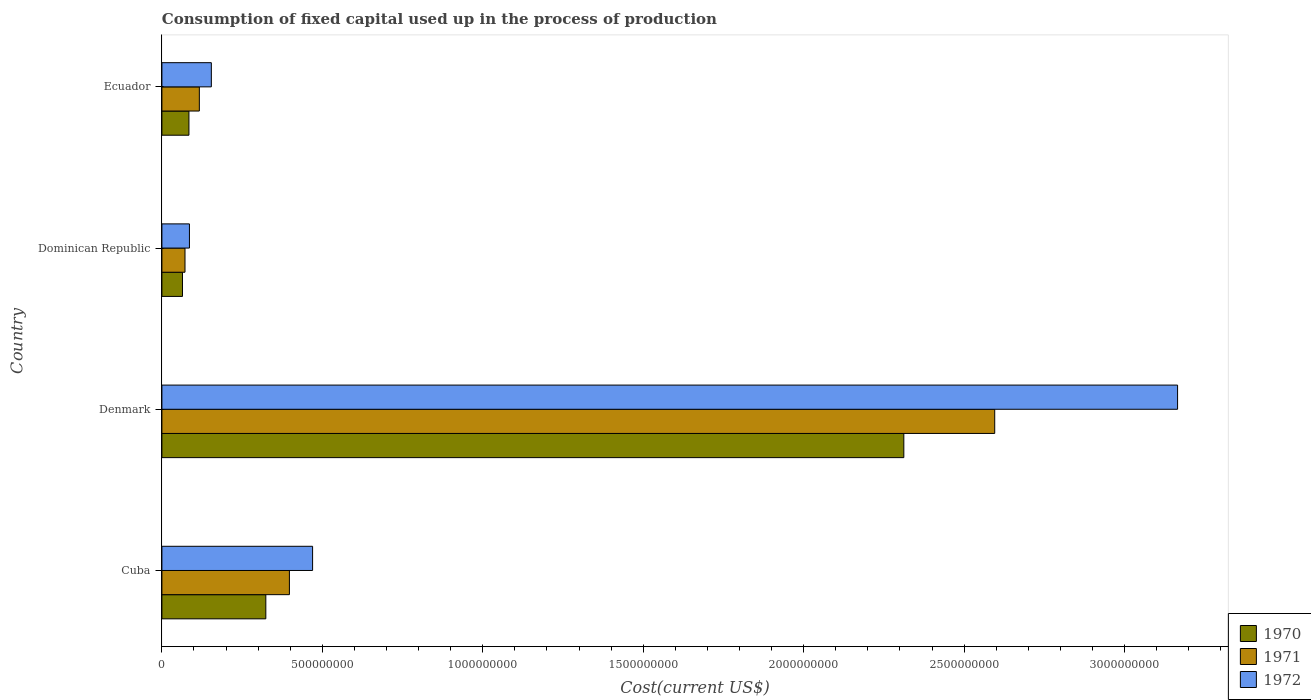How many groups of bars are there?
Your answer should be compact. 4. Are the number of bars per tick equal to the number of legend labels?
Offer a terse response. Yes. Are the number of bars on each tick of the Y-axis equal?
Provide a succinct answer. Yes. How many bars are there on the 4th tick from the top?
Your response must be concise. 3. How many bars are there on the 1st tick from the bottom?
Offer a very short reply. 3. What is the label of the 2nd group of bars from the top?
Provide a succinct answer. Dominican Republic. What is the amount consumed in the process of production in 1972 in Ecuador?
Keep it short and to the point. 1.54e+08. Across all countries, what is the maximum amount consumed in the process of production in 1972?
Provide a short and direct response. 3.17e+09. Across all countries, what is the minimum amount consumed in the process of production in 1971?
Provide a succinct answer. 7.20e+07. In which country was the amount consumed in the process of production in 1971 maximum?
Your response must be concise. Denmark. In which country was the amount consumed in the process of production in 1970 minimum?
Provide a succinct answer. Dominican Republic. What is the total amount consumed in the process of production in 1970 in the graph?
Offer a terse response. 2.78e+09. What is the difference between the amount consumed in the process of production in 1971 in Cuba and that in Ecuador?
Offer a very short reply. 2.81e+08. What is the difference between the amount consumed in the process of production in 1971 in Denmark and the amount consumed in the process of production in 1970 in Dominican Republic?
Offer a very short reply. 2.53e+09. What is the average amount consumed in the process of production in 1971 per country?
Offer a very short reply. 7.95e+08. What is the difference between the amount consumed in the process of production in 1970 and amount consumed in the process of production in 1972 in Denmark?
Your response must be concise. -8.53e+08. What is the ratio of the amount consumed in the process of production in 1972 in Dominican Republic to that in Ecuador?
Your answer should be compact. 0.56. What is the difference between the highest and the second highest amount consumed in the process of production in 1970?
Give a very brief answer. 1.99e+09. What is the difference between the highest and the lowest amount consumed in the process of production in 1972?
Offer a terse response. 3.08e+09. Is the sum of the amount consumed in the process of production in 1972 in Cuba and Ecuador greater than the maximum amount consumed in the process of production in 1970 across all countries?
Give a very brief answer. No. What does the 2nd bar from the top in Ecuador represents?
Your response must be concise. 1971. What does the 2nd bar from the bottom in Denmark represents?
Keep it short and to the point. 1971. Are all the bars in the graph horizontal?
Ensure brevity in your answer.  Yes. How many countries are there in the graph?
Your answer should be compact. 4. What is the difference between two consecutive major ticks on the X-axis?
Make the answer very short. 5.00e+08. Are the values on the major ticks of X-axis written in scientific E-notation?
Your answer should be very brief. No. Where does the legend appear in the graph?
Give a very brief answer. Bottom right. How are the legend labels stacked?
Ensure brevity in your answer.  Vertical. What is the title of the graph?
Make the answer very short. Consumption of fixed capital used up in the process of production. Does "1980" appear as one of the legend labels in the graph?
Provide a short and direct response. No. What is the label or title of the X-axis?
Offer a very short reply. Cost(current US$). What is the Cost(current US$) of 1970 in Cuba?
Provide a short and direct response. 3.24e+08. What is the Cost(current US$) of 1971 in Cuba?
Provide a short and direct response. 3.97e+08. What is the Cost(current US$) of 1972 in Cuba?
Provide a short and direct response. 4.70e+08. What is the Cost(current US$) of 1970 in Denmark?
Make the answer very short. 2.31e+09. What is the Cost(current US$) in 1971 in Denmark?
Your answer should be compact. 2.60e+09. What is the Cost(current US$) in 1972 in Denmark?
Your answer should be very brief. 3.17e+09. What is the Cost(current US$) of 1970 in Dominican Republic?
Ensure brevity in your answer.  6.41e+07. What is the Cost(current US$) of 1971 in Dominican Republic?
Offer a terse response. 7.20e+07. What is the Cost(current US$) of 1972 in Dominican Republic?
Your response must be concise. 8.58e+07. What is the Cost(current US$) in 1970 in Ecuador?
Make the answer very short. 8.43e+07. What is the Cost(current US$) of 1971 in Ecuador?
Ensure brevity in your answer.  1.17e+08. What is the Cost(current US$) in 1972 in Ecuador?
Offer a terse response. 1.54e+08. Across all countries, what is the maximum Cost(current US$) of 1970?
Your answer should be compact. 2.31e+09. Across all countries, what is the maximum Cost(current US$) of 1971?
Provide a succinct answer. 2.60e+09. Across all countries, what is the maximum Cost(current US$) in 1972?
Provide a succinct answer. 3.17e+09. Across all countries, what is the minimum Cost(current US$) in 1970?
Your response must be concise. 6.41e+07. Across all countries, what is the minimum Cost(current US$) of 1971?
Your answer should be very brief. 7.20e+07. Across all countries, what is the minimum Cost(current US$) in 1972?
Give a very brief answer. 8.58e+07. What is the total Cost(current US$) of 1970 in the graph?
Offer a very short reply. 2.78e+09. What is the total Cost(current US$) in 1971 in the graph?
Give a very brief answer. 3.18e+09. What is the total Cost(current US$) of 1972 in the graph?
Provide a short and direct response. 3.87e+09. What is the difference between the Cost(current US$) of 1970 in Cuba and that in Denmark?
Keep it short and to the point. -1.99e+09. What is the difference between the Cost(current US$) of 1971 in Cuba and that in Denmark?
Offer a very short reply. -2.20e+09. What is the difference between the Cost(current US$) in 1972 in Cuba and that in Denmark?
Keep it short and to the point. -2.70e+09. What is the difference between the Cost(current US$) of 1970 in Cuba and that in Dominican Republic?
Make the answer very short. 2.60e+08. What is the difference between the Cost(current US$) in 1971 in Cuba and that in Dominican Republic?
Keep it short and to the point. 3.25e+08. What is the difference between the Cost(current US$) in 1972 in Cuba and that in Dominican Republic?
Provide a short and direct response. 3.84e+08. What is the difference between the Cost(current US$) in 1970 in Cuba and that in Ecuador?
Provide a succinct answer. 2.40e+08. What is the difference between the Cost(current US$) in 1971 in Cuba and that in Ecuador?
Offer a terse response. 2.81e+08. What is the difference between the Cost(current US$) in 1972 in Cuba and that in Ecuador?
Keep it short and to the point. 3.16e+08. What is the difference between the Cost(current US$) in 1970 in Denmark and that in Dominican Republic?
Your response must be concise. 2.25e+09. What is the difference between the Cost(current US$) in 1971 in Denmark and that in Dominican Republic?
Give a very brief answer. 2.52e+09. What is the difference between the Cost(current US$) of 1972 in Denmark and that in Dominican Republic?
Offer a terse response. 3.08e+09. What is the difference between the Cost(current US$) of 1970 in Denmark and that in Ecuador?
Give a very brief answer. 2.23e+09. What is the difference between the Cost(current US$) of 1971 in Denmark and that in Ecuador?
Make the answer very short. 2.48e+09. What is the difference between the Cost(current US$) in 1972 in Denmark and that in Ecuador?
Offer a very short reply. 3.01e+09. What is the difference between the Cost(current US$) in 1970 in Dominican Republic and that in Ecuador?
Your response must be concise. -2.01e+07. What is the difference between the Cost(current US$) of 1971 in Dominican Republic and that in Ecuador?
Offer a very short reply. -4.47e+07. What is the difference between the Cost(current US$) in 1972 in Dominican Republic and that in Ecuador?
Make the answer very short. -6.83e+07. What is the difference between the Cost(current US$) in 1970 in Cuba and the Cost(current US$) in 1971 in Denmark?
Offer a very short reply. -2.27e+09. What is the difference between the Cost(current US$) of 1970 in Cuba and the Cost(current US$) of 1972 in Denmark?
Offer a very short reply. -2.84e+09. What is the difference between the Cost(current US$) of 1971 in Cuba and the Cost(current US$) of 1972 in Denmark?
Give a very brief answer. -2.77e+09. What is the difference between the Cost(current US$) of 1970 in Cuba and the Cost(current US$) of 1971 in Dominican Republic?
Your answer should be compact. 2.52e+08. What is the difference between the Cost(current US$) of 1970 in Cuba and the Cost(current US$) of 1972 in Dominican Republic?
Give a very brief answer. 2.38e+08. What is the difference between the Cost(current US$) in 1971 in Cuba and the Cost(current US$) in 1972 in Dominican Republic?
Give a very brief answer. 3.12e+08. What is the difference between the Cost(current US$) in 1970 in Cuba and the Cost(current US$) in 1971 in Ecuador?
Ensure brevity in your answer.  2.07e+08. What is the difference between the Cost(current US$) of 1970 in Cuba and the Cost(current US$) of 1972 in Ecuador?
Ensure brevity in your answer.  1.70e+08. What is the difference between the Cost(current US$) in 1971 in Cuba and the Cost(current US$) in 1972 in Ecuador?
Provide a succinct answer. 2.43e+08. What is the difference between the Cost(current US$) in 1970 in Denmark and the Cost(current US$) in 1971 in Dominican Republic?
Ensure brevity in your answer.  2.24e+09. What is the difference between the Cost(current US$) of 1970 in Denmark and the Cost(current US$) of 1972 in Dominican Republic?
Offer a terse response. 2.23e+09. What is the difference between the Cost(current US$) of 1971 in Denmark and the Cost(current US$) of 1972 in Dominican Republic?
Offer a very short reply. 2.51e+09. What is the difference between the Cost(current US$) in 1970 in Denmark and the Cost(current US$) in 1971 in Ecuador?
Your answer should be very brief. 2.20e+09. What is the difference between the Cost(current US$) in 1970 in Denmark and the Cost(current US$) in 1972 in Ecuador?
Offer a very short reply. 2.16e+09. What is the difference between the Cost(current US$) of 1971 in Denmark and the Cost(current US$) of 1972 in Ecuador?
Your answer should be very brief. 2.44e+09. What is the difference between the Cost(current US$) in 1970 in Dominican Republic and the Cost(current US$) in 1971 in Ecuador?
Offer a terse response. -5.25e+07. What is the difference between the Cost(current US$) in 1970 in Dominican Republic and the Cost(current US$) in 1972 in Ecuador?
Your response must be concise. -9.00e+07. What is the difference between the Cost(current US$) in 1971 in Dominican Republic and the Cost(current US$) in 1972 in Ecuador?
Your answer should be very brief. -8.21e+07. What is the average Cost(current US$) of 1970 per country?
Keep it short and to the point. 6.96e+08. What is the average Cost(current US$) in 1971 per country?
Your answer should be compact. 7.95e+08. What is the average Cost(current US$) of 1972 per country?
Offer a very short reply. 9.69e+08. What is the difference between the Cost(current US$) in 1970 and Cost(current US$) in 1971 in Cuba?
Make the answer very short. -7.35e+07. What is the difference between the Cost(current US$) in 1970 and Cost(current US$) in 1972 in Cuba?
Provide a succinct answer. -1.46e+08. What is the difference between the Cost(current US$) in 1971 and Cost(current US$) in 1972 in Cuba?
Offer a terse response. -7.23e+07. What is the difference between the Cost(current US$) of 1970 and Cost(current US$) of 1971 in Denmark?
Your answer should be compact. -2.83e+08. What is the difference between the Cost(current US$) in 1970 and Cost(current US$) in 1972 in Denmark?
Your answer should be very brief. -8.53e+08. What is the difference between the Cost(current US$) of 1971 and Cost(current US$) of 1972 in Denmark?
Provide a short and direct response. -5.70e+08. What is the difference between the Cost(current US$) in 1970 and Cost(current US$) in 1971 in Dominican Republic?
Your response must be concise. -7.86e+06. What is the difference between the Cost(current US$) of 1970 and Cost(current US$) of 1972 in Dominican Republic?
Offer a very short reply. -2.17e+07. What is the difference between the Cost(current US$) of 1971 and Cost(current US$) of 1972 in Dominican Republic?
Give a very brief answer. -1.38e+07. What is the difference between the Cost(current US$) of 1970 and Cost(current US$) of 1971 in Ecuador?
Make the answer very short. -3.24e+07. What is the difference between the Cost(current US$) of 1970 and Cost(current US$) of 1972 in Ecuador?
Your answer should be compact. -6.99e+07. What is the difference between the Cost(current US$) in 1971 and Cost(current US$) in 1972 in Ecuador?
Make the answer very short. -3.74e+07. What is the ratio of the Cost(current US$) of 1970 in Cuba to that in Denmark?
Provide a succinct answer. 0.14. What is the ratio of the Cost(current US$) of 1971 in Cuba to that in Denmark?
Keep it short and to the point. 0.15. What is the ratio of the Cost(current US$) of 1972 in Cuba to that in Denmark?
Give a very brief answer. 0.15. What is the ratio of the Cost(current US$) of 1970 in Cuba to that in Dominican Republic?
Your answer should be very brief. 5.05. What is the ratio of the Cost(current US$) in 1971 in Cuba to that in Dominican Republic?
Provide a short and direct response. 5.52. What is the ratio of the Cost(current US$) in 1972 in Cuba to that in Dominican Republic?
Provide a short and direct response. 5.47. What is the ratio of the Cost(current US$) of 1970 in Cuba to that in Ecuador?
Keep it short and to the point. 3.84. What is the ratio of the Cost(current US$) of 1971 in Cuba to that in Ecuador?
Your answer should be very brief. 3.41. What is the ratio of the Cost(current US$) of 1972 in Cuba to that in Ecuador?
Keep it short and to the point. 3.05. What is the ratio of the Cost(current US$) in 1970 in Denmark to that in Dominican Republic?
Your response must be concise. 36.05. What is the ratio of the Cost(current US$) of 1971 in Denmark to that in Dominican Republic?
Give a very brief answer. 36.05. What is the ratio of the Cost(current US$) of 1972 in Denmark to that in Dominican Republic?
Your answer should be compact. 36.89. What is the ratio of the Cost(current US$) of 1970 in Denmark to that in Ecuador?
Your answer should be compact. 27.44. What is the ratio of the Cost(current US$) in 1971 in Denmark to that in Ecuador?
Your response must be concise. 22.25. What is the ratio of the Cost(current US$) in 1972 in Denmark to that in Ecuador?
Provide a short and direct response. 20.54. What is the ratio of the Cost(current US$) in 1970 in Dominican Republic to that in Ecuador?
Your answer should be very brief. 0.76. What is the ratio of the Cost(current US$) of 1971 in Dominican Republic to that in Ecuador?
Offer a terse response. 0.62. What is the ratio of the Cost(current US$) of 1972 in Dominican Republic to that in Ecuador?
Ensure brevity in your answer.  0.56. What is the difference between the highest and the second highest Cost(current US$) in 1970?
Your answer should be compact. 1.99e+09. What is the difference between the highest and the second highest Cost(current US$) of 1971?
Give a very brief answer. 2.20e+09. What is the difference between the highest and the second highest Cost(current US$) in 1972?
Provide a short and direct response. 2.70e+09. What is the difference between the highest and the lowest Cost(current US$) of 1970?
Make the answer very short. 2.25e+09. What is the difference between the highest and the lowest Cost(current US$) in 1971?
Your answer should be compact. 2.52e+09. What is the difference between the highest and the lowest Cost(current US$) in 1972?
Give a very brief answer. 3.08e+09. 